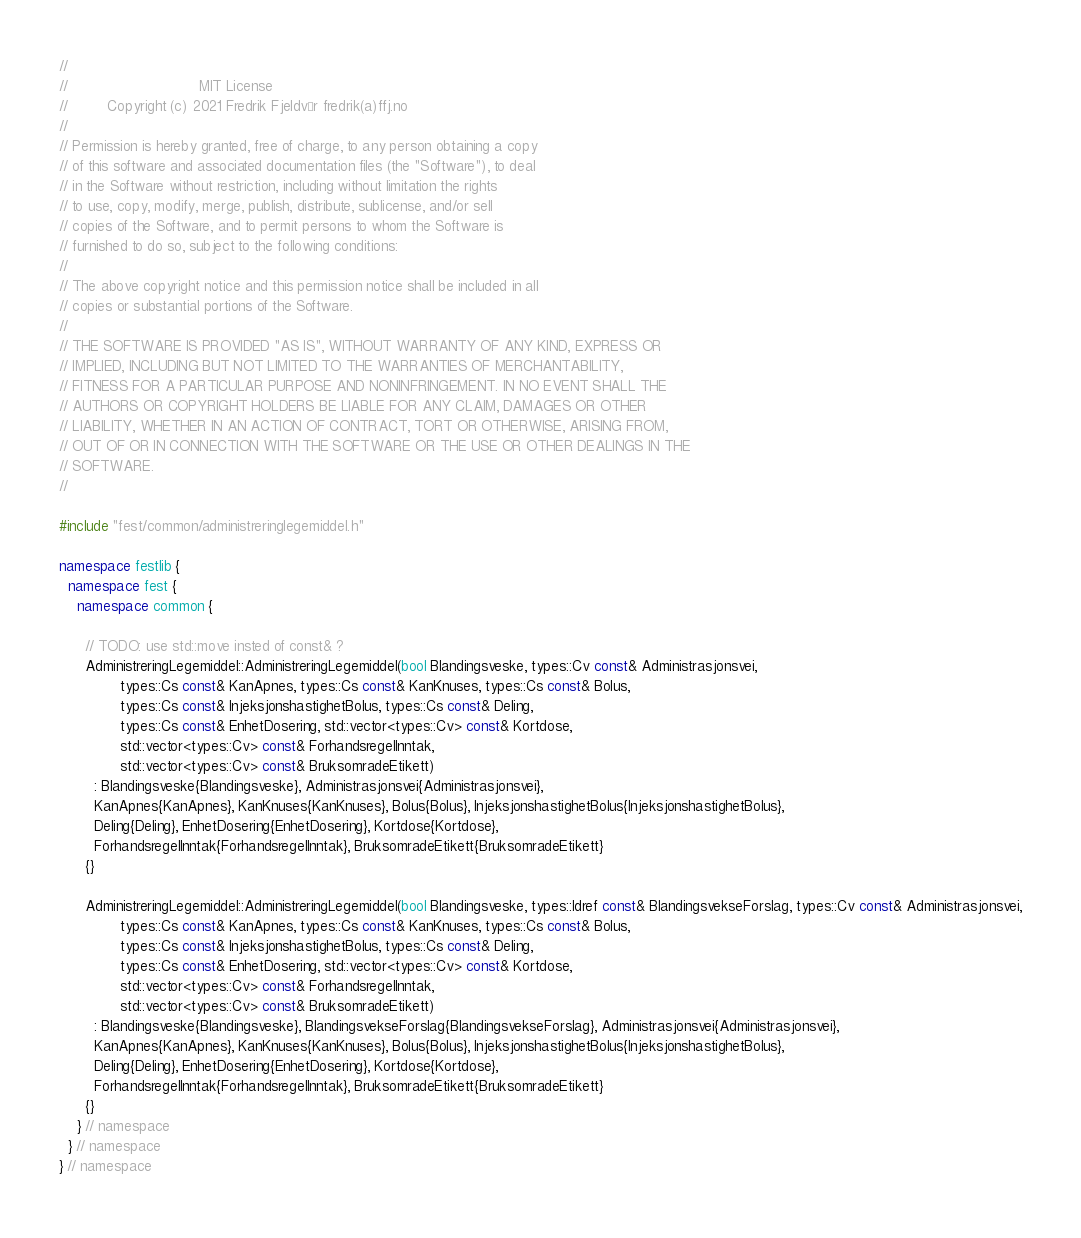Convert code to text. <code><loc_0><loc_0><loc_500><loc_500><_C++_>//
//                              MIT License
//         Copyright (c) 2021 Fredrik Fjeldvær fredrik(a)ffj.no
//
// Permission is hereby granted, free of charge, to any person obtaining a copy
// of this software and associated documentation files (the "Software"), to deal
// in the Software without restriction, including without limitation the rights
// to use, copy, modify, merge, publish, distribute, sublicense, and/or sell
// copies of the Software, and to permit persons to whom the Software is
// furnished to do so, subject to the following conditions:
//
// The above copyright notice and this permission notice shall be included in all
// copies or substantial portions of the Software.
//
// THE SOFTWARE IS PROVIDED "AS IS", WITHOUT WARRANTY OF ANY KIND, EXPRESS OR
// IMPLIED, INCLUDING BUT NOT LIMITED TO THE WARRANTIES OF MERCHANTABILITY,
// FITNESS FOR A PARTICULAR PURPOSE AND NONINFRINGEMENT. IN NO EVENT SHALL THE
// AUTHORS OR COPYRIGHT HOLDERS BE LIABLE FOR ANY CLAIM, DAMAGES OR OTHER
// LIABILITY, WHETHER IN AN ACTION OF CONTRACT, TORT OR OTHERWISE, ARISING FROM,
// OUT OF OR IN CONNECTION WITH THE SOFTWARE OR THE USE OR OTHER DEALINGS IN THE
// SOFTWARE.
//

#include "fest/common/administreringlegemiddel.h"

namespace festlib {
  namespace fest {
    namespace common {

      // TODO: use std::move insted of const& ?
      AdministreringLegemiddel::AdministreringLegemiddel(bool Blandingsveske, types::Cv const& Administrasjonsvei,
              types::Cs const& KanApnes, types::Cs const& KanKnuses, types::Cs const& Bolus,
              types::Cs const& InjeksjonshastighetBolus, types::Cs const& Deling,
              types::Cs const& EnhetDosering, std::vector<types::Cv> const& Kortdose,
              std::vector<types::Cv> const& ForhandsregelInntak,
              std::vector<types::Cv> const& BruksomradeEtikett)
        : Blandingsveske{Blandingsveske}, Administrasjonsvei{Administrasjonsvei},
        KanApnes{KanApnes}, KanKnuses{KanKnuses}, Bolus{Bolus}, InjeksjonshastighetBolus{InjeksjonshastighetBolus},
        Deling{Deling}, EnhetDosering{EnhetDosering}, Kortdose{Kortdose},
        ForhandsregelInntak{ForhandsregelInntak}, BruksomradeEtikett{BruksomradeEtikett}
      {}

      AdministreringLegemiddel::AdministreringLegemiddel(bool Blandingsveske, types::Idref const& BlandingsvekseForslag, types::Cv const& Administrasjonsvei,
              types::Cs const& KanApnes, types::Cs const& KanKnuses, types::Cs const& Bolus,
              types::Cs const& InjeksjonshastighetBolus, types::Cs const& Deling,
              types::Cs const& EnhetDosering, std::vector<types::Cv> const& Kortdose,
              std::vector<types::Cv> const& ForhandsregelInntak,
              std::vector<types::Cv> const& BruksomradeEtikett)
        : Blandingsveske{Blandingsveske}, BlandingsvekseForslag{BlandingsvekseForslag}, Administrasjonsvei{Administrasjonsvei},
        KanApnes{KanApnes}, KanKnuses{KanKnuses}, Bolus{Bolus}, InjeksjonshastighetBolus{InjeksjonshastighetBolus},
        Deling{Deling}, EnhetDosering{EnhetDosering}, Kortdose{Kortdose},
        ForhandsregelInntak{ForhandsregelInntak}, BruksomradeEtikett{BruksomradeEtikett}
      {}
    } // namespace
  } // namespace
} // namespace

</code> 